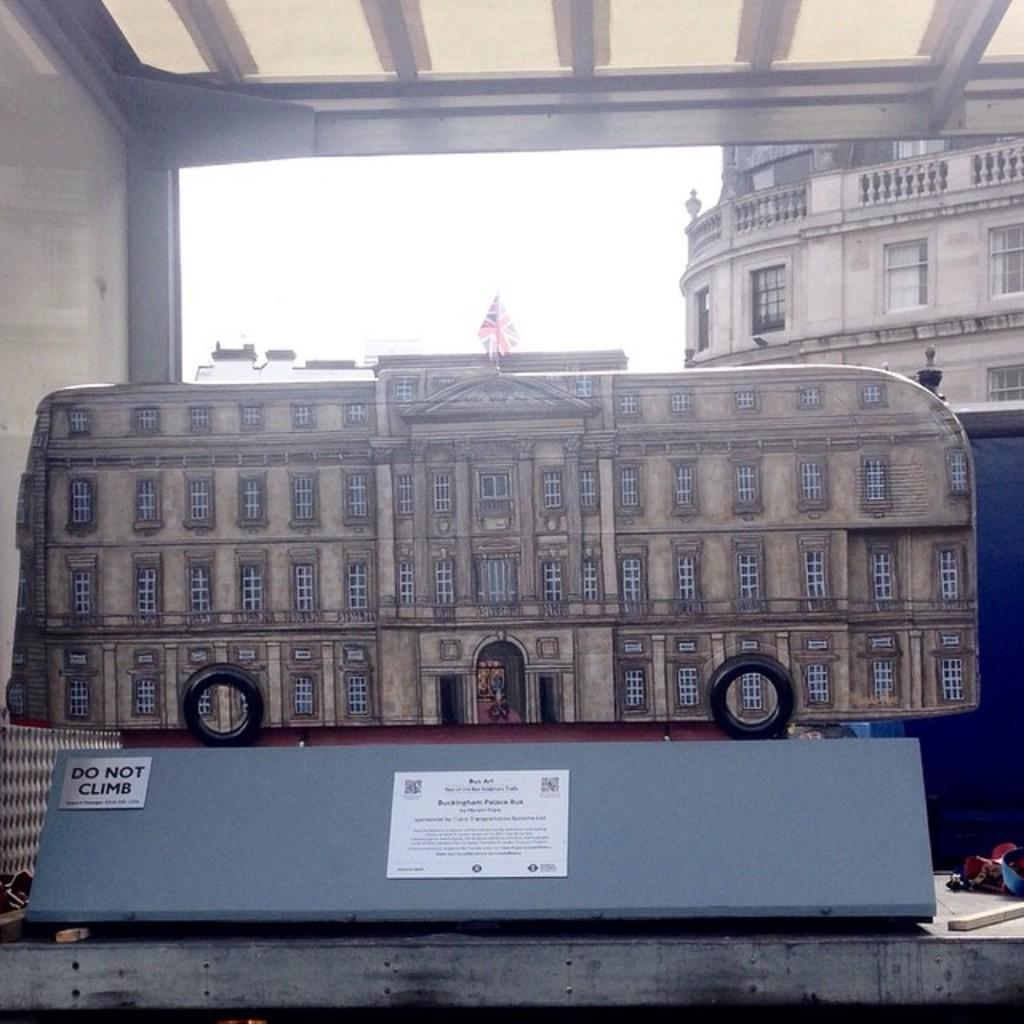What type of art is featured in the image? There is an art of a duplicate building in the image. What else can be seen attached to a wooden board in the image? There are posters attached to a wooden board in the image. What kind of structures are visible in the image? There are buildings visible in the image. What object is made of wood and can be seen in the image? There is a wooden stick in the image. What type of symbol is present in the image? There is a flag in the image. What part of the natural environment is visible in the image? The sky is visible in the image. What type of shoe is being advertised on the wooden board in the image? There is no shoe being advertised on the wooden board in the image; it features posters with an art of a duplicate building and other content. Can you tell me how many farmers are present in the image? There are no farmers present in the image. 